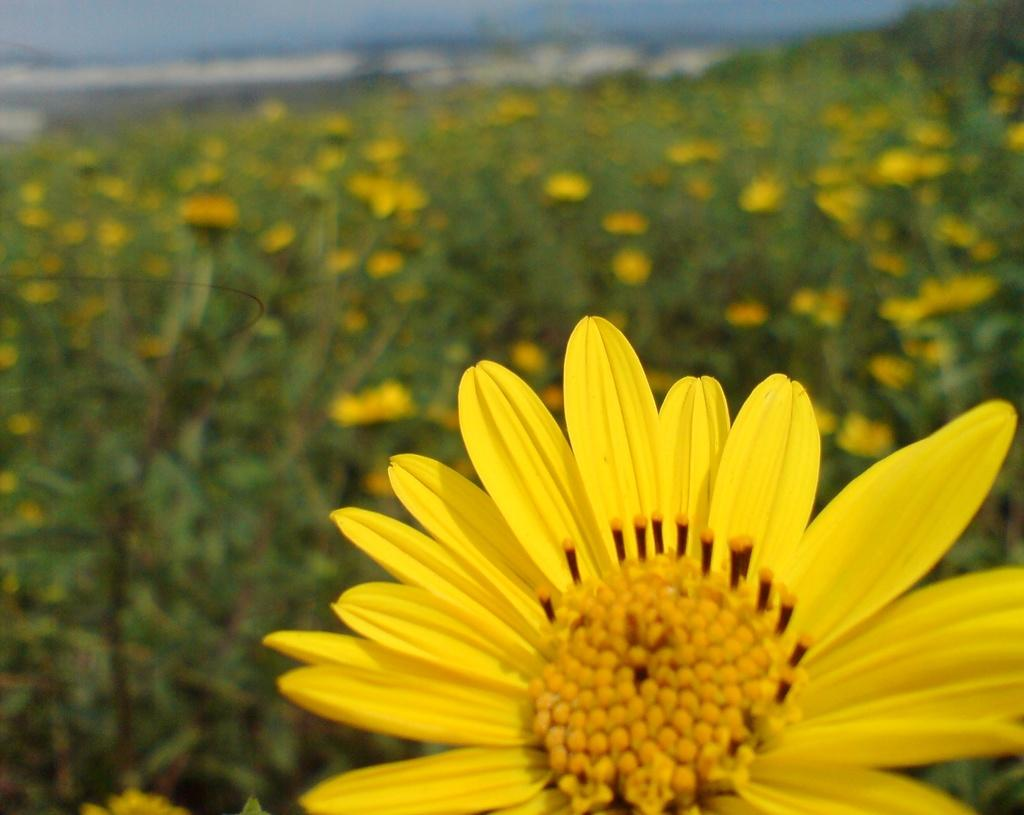Where was the picture taken? The picture was clicked outside. What is the main subject in the foreground of the image? There is a flower in the foreground of the image. What can be seen in the background of the image? There are flowers, plants, and other items visible in the background of the image. How many cows are visible in the image? There are no cows present in the image. What type of scarf is being worn by the flower in the foreground? The flower in the foreground is not wearing a scarf, as it is a plant and not a person. 